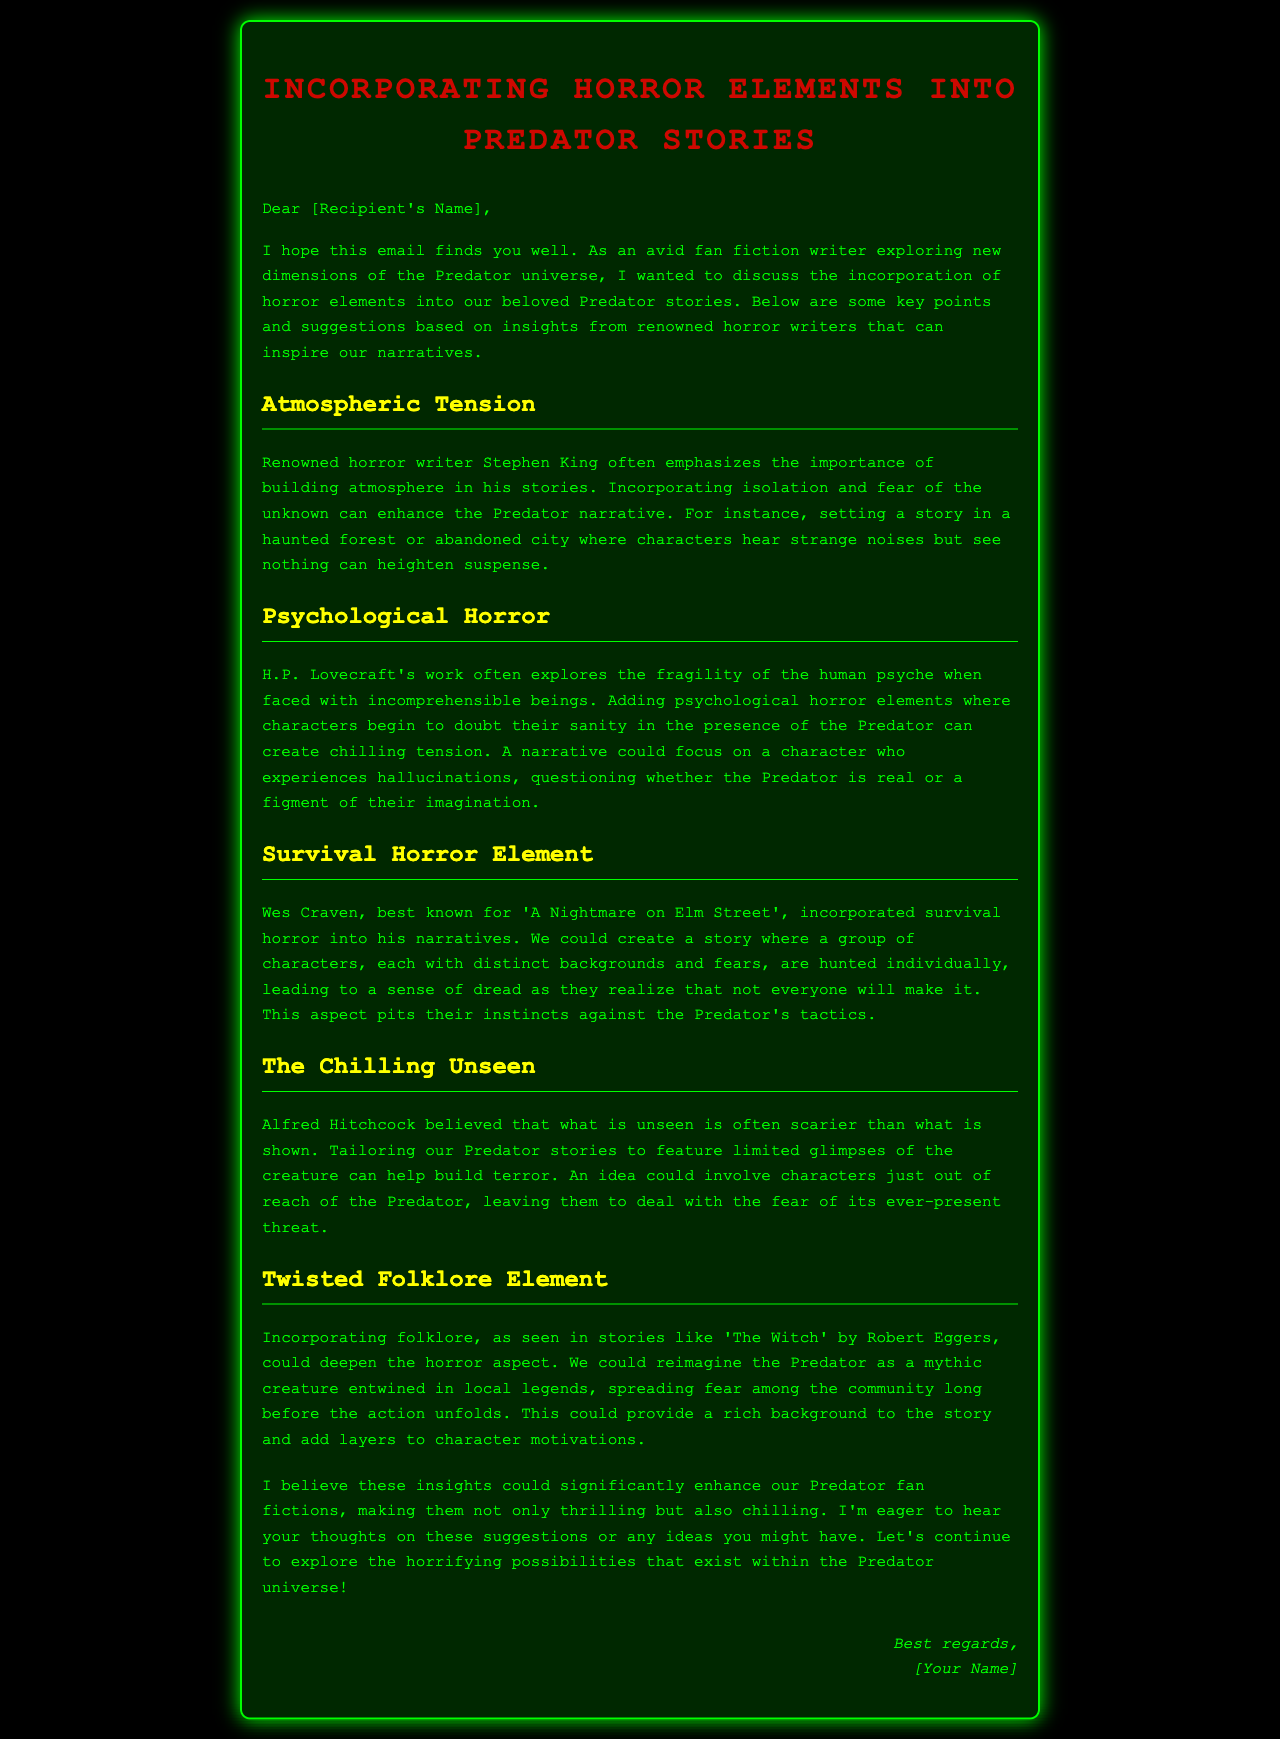What is the main topic of the email? The email discusses incorporating horror elements into Predator stories.
Answer: Incorporating horror elements into Predator stories Who is a renowned horror writer mentioned in the document? Stephen King is mentioned, highlighting his emphasis on building atmosphere.
Answer: Stephen King What type of horror does H.P. Lovecraft explore? H.P. Lovecraft's work explores psychological horror and the fragility of the human psyche.
Answer: Psychological horror What survival horror element is suggested? The suggested element involves characters being hunted individually by the Predator.
Answer: Characters being hunted individually Which filmmaker's belief is mentioned regarding the unseen? Alfred Hitchcock's belief that what is unseen is scarier than what is shown is mentioned.
Answer: Alfred Hitchcock What folklore element is suggested for Predator stories? Incorporating local legends to reimagine the Predator as a mythic creature is suggested.
Answer: Local legends How many distinct backgrounds do the characters have in the survival horror suggestion? The characters have distinct backgrounds, suggesting a variety among them.
Answer: Distinct backgrounds What is the intention of the email? The intention is to enhance Predator fan fictions with horror elements.
Answer: Enhance Predator fan fictions 